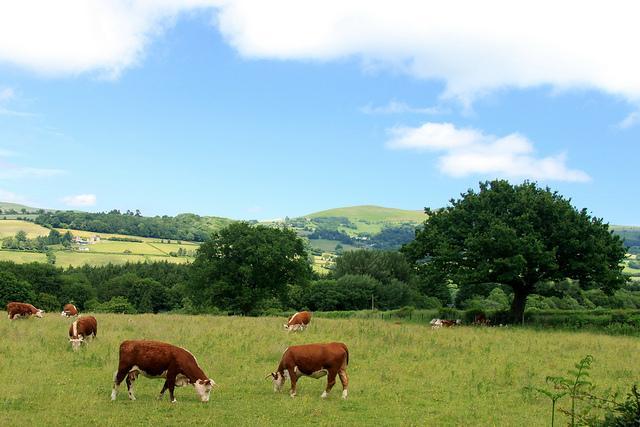These animals usually live where? Please explain your reasoning. pasture. The animals are on a grassy pasture. 